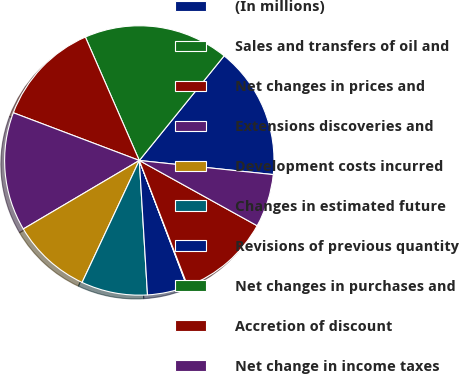Convert chart to OTSL. <chart><loc_0><loc_0><loc_500><loc_500><pie_chart><fcel>(In millions)<fcel>Sales and transfers of oil and<fcel>Net changes in prices and<fcel>Extensions discoveries and<fcel>Development costs incurred<fcel>Changes in estimated future<fcel>Revisions of previous quantity<fcel>Net changes in purchases and<fcel>Accretion of discount<fcel>Net change in income taxes<nl><fcel>15.83%<fcel>17.4%<fcel>12.68%<fcel>14.25%<fcel>9.53%<fcel>7.95%<fcel>4.8%<fcel>0.08%<fcel>11.1%<fcel>6.38%<nl></chart> 